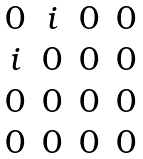<formula> <loc_0><loc_0><loc_500><loc_500>\begin{matrix} 0 & i & 0 & 0 \\ i & 0 & 0 & 0 \\ 0 & 0 & 0 & 0 \\ 0 & 0 & 0 & 0 \end{matrix}</formula> 